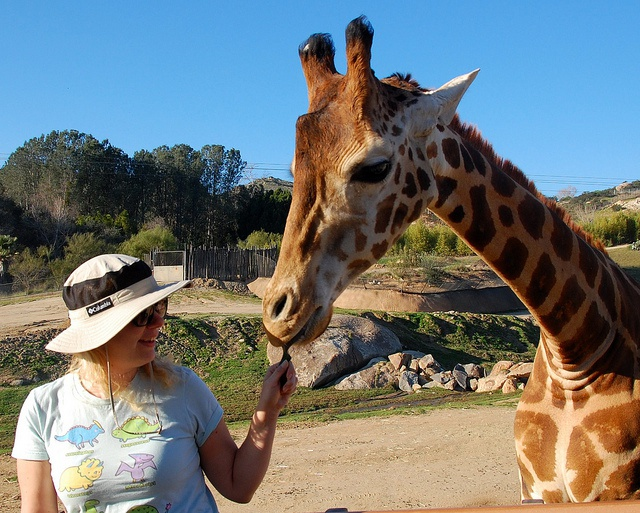Describe the objects in this image and their specific colors. I can see giraffe in lightblue, black, maroon, brown, and tan tones and people in lightblue, white, gray, maroon, and black tones in this image. 